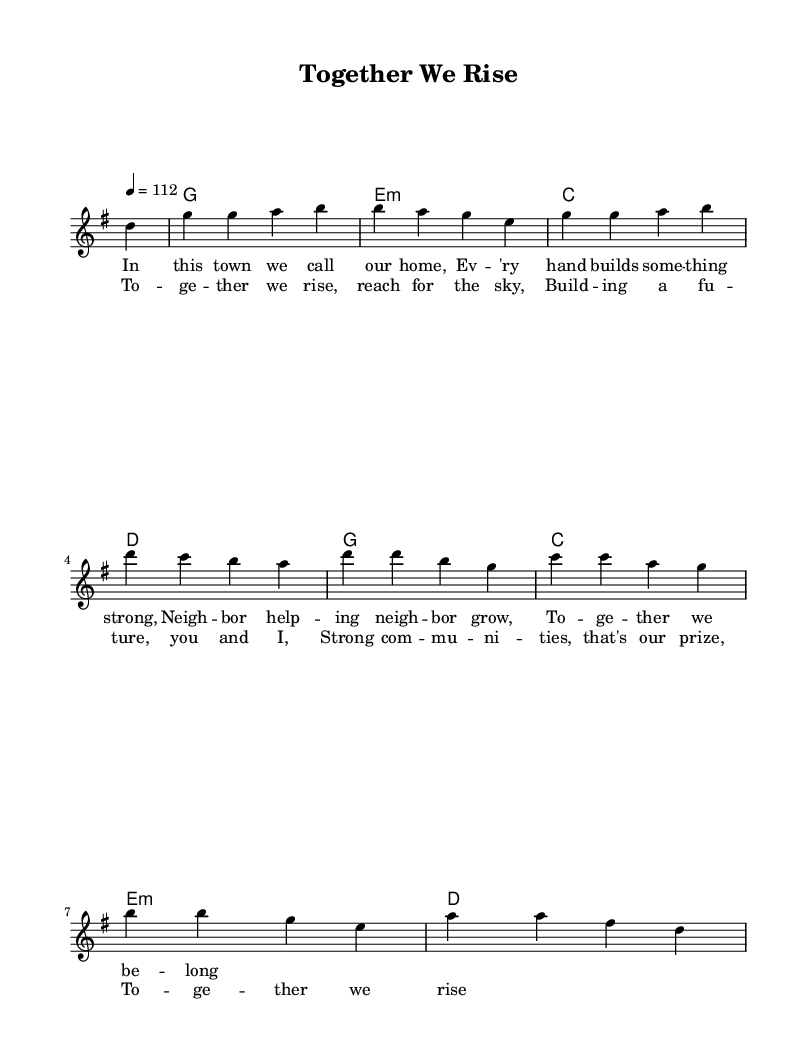What is the key signature of this music? The key signature is G major, which has one sharp (F#). This can be identified by checking the signature at the beginning of the staff.
Answer: G major What is the time signature of this music? The time signature is 4/4. This information is located at the beginning of the score, clearly indicating that there are four beats per measure.
Answer: 4/4 What is the tempo marking for this music? The tempo marking is 112 beats per minute. This is specified at the beginning of the score as "4 = 112," meaning the quarter note gets the beat at this speed.
Answer: 112 How many measures are there in the melody? The melody consists of 8 measures. By counting each unique segment of music separated by vertical lines on the score, we find a total of eight.
Answer: 8 What is the main theme of the chorus? The main theme of the chorus is about rising together to build strong communities. Analyzing the lyrics, the focus is on collaboration and sharing a common purpose.
Answer: Rising together Which chords are primarily used in this piece? The primary chords used are G, E minor, C, and D. These chords appear repeatedly throughout the harmonic progression, reflecting typical country rock chord structures.
Answer: G, E minor, C, D What type of lyrical structure is used in this track? The lyrical structure includes verses and a chorus, which is common in country rock songs. The format alternates between storytelling in the verses and a repetitive, uplifting message in the chorus.
Answer: Verse and chorus 